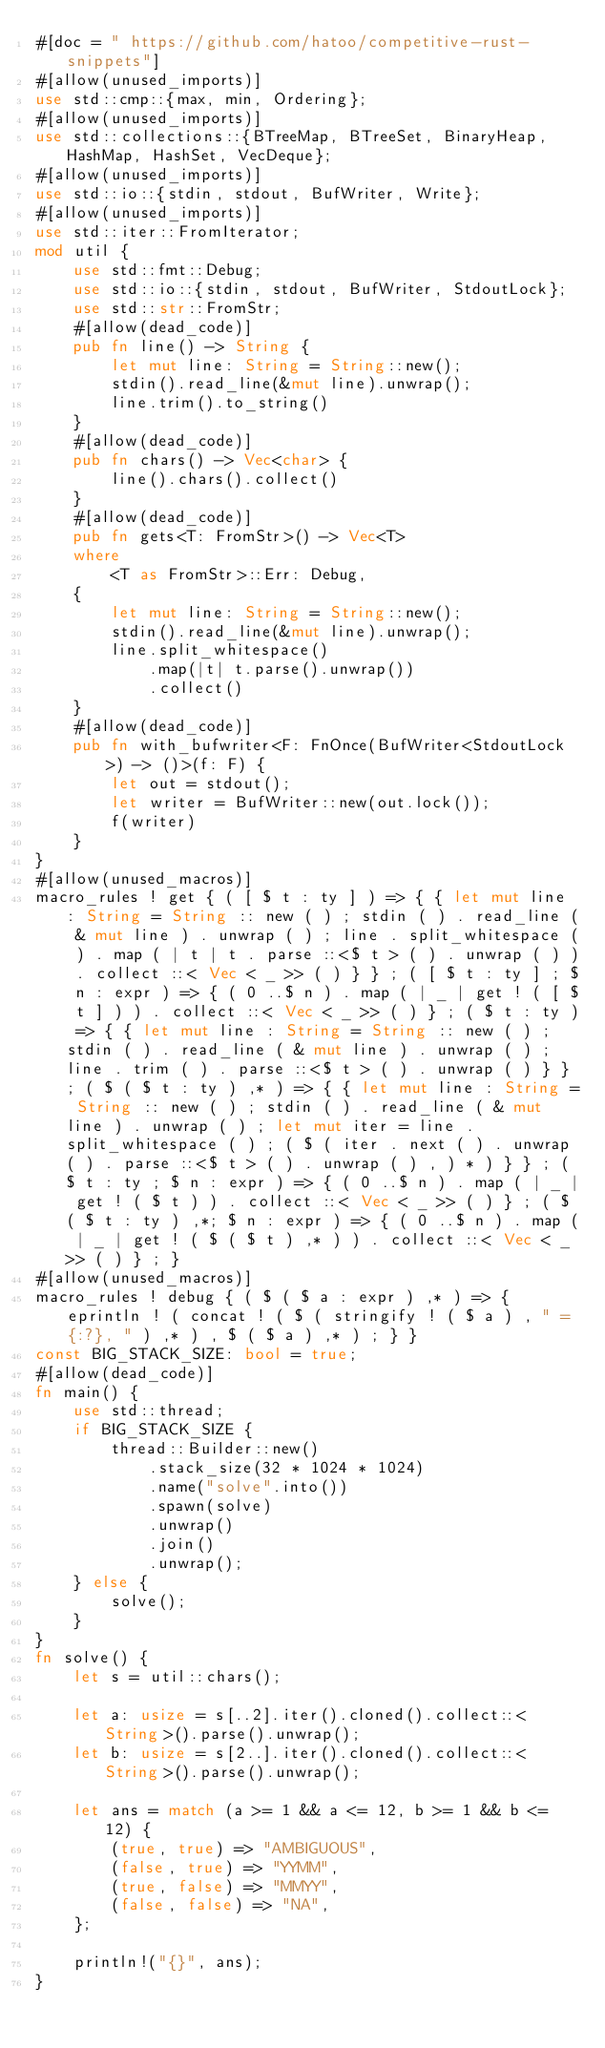Convert code to text. <code><loc_0><loc_0><loc_500><loc_500><_Rust_>#[doc = " https://github.com/hatoo/competitive-rust-snippets"]
#[allow(unused_imports)]
use std::cmp::{max, min, Ordering};
#[allow(unused_imports)]
use std::collections::{BTreeMap, BTreeSet, BinaryHeap, HashMap, HashSet, VecDeque};
#[allow(unused_imports)]
use std::io::{stdin, stdout, BufWriter, Write};
#[allow(unused_imports)]
use std::iter::FromIterator;
mod util {
    use std::fmt::Debug;
    use std::io::{stdin, stdout, BufWriter, StdoutLock};
    use std::str::FromStr;
    #[allow(dead_code)]
    pub fn line() -> String {
        let mut line: String = String::new();
        stdin().read_line(&mut line).unwrap();
        line.trim().to_string()
    }
    #[allow(dead_code)]
    pub fn chars() -> Vec<char> {
        line().chars().collect()
    }
    #[allow(dead_code)]
    pub fn gets<T: FromStr>() -> Vec<T>
    where
        <T as FromStr>::Err: Debug,
    {
        let mut line: String = String::new();
        stdin().read_line(&mut line).unwrap();
        line.split_whitespace()
            .map(|t| t.parse().unwrap())
            .collect()
    }
    #[allow(dead_code)]
    pub fn with_bufwriter<F: FnOnce(BufWriter<StdoutLock>) -> ()>(f: F) {
        let out = stdout();
        let writer = BufWriter::new(out.lock());
        f(writer)
    }
}
#[allow(unused_macros)]
macro_rules ! get { ( [ $ t : ty ] ) => { { let mut line : String = String :: new ( ) ; stdin ( ) . read_line ( & mut line ) . unwrap ( ) ; line . split_whitespace ( ) . map ( | t | t . parse ::<$ t > ( ) . unwrap ( ) ) . collect ::< Vec < _ >> ( ) } } ; ( [ $ t : ty ] ; $ n : expr ) => { ( 0 ..$ n ) . map ( | _ | get ! ( [ $ t ] ) ) . collect ::< Vec < _ >> ( ) } ; ( $ t : ty ) => { { let mut line : String = String :: new ( ) ; stdin ( ) . read_line ( & mut line ) . unwrap ( ) ; line . trim ( ) . parse ::<$ t > ( ) . unwrap ( ) } } ; ( $ ( $ t : ty ) ,* ) => { { let mut line : String = String :: new ( ) ; stdin ( ) . read_line ( & mut line ) . unwrap ( ) ; let mut iter = line . split_whitespace ( ) ; ( $ ( iter . next ( ) . unwrap ( ) . parse ::<$ t > ( ) . unwrap ( ) , ) * ) } } ; ( $ t : ty ; $ n : expr ) => { ( 0 ..$ n ) . map ( | _ | get ! ( $ t ) ) . collect ::< Vec < _ >> ( ) } ; ( $ ( $ t : ty ) ,*; $ n : expr ) => { ( 0 ..$ n ) . map ( | _ | get ! ( $ ( $ t ) ,* ) ) . collect ::< Vec < _ >> ( ) } ; }
#[allow(unused_macros)]
macro_rules ! debug { ( $ ( $ a : expr ) ,* ) => { eprintln ! ( concat ! ( $ ( stringify ! ( $ a ) , " = {:?}, " ) ,* ) , $ ( $ a ) ,* ) ; } }
const BIG_STACK_SIZE: bool = true;
#[allow(dead_code)]
fn main() {
    use std::thread;
    if BIG_STACK_SIZE {
        thread::Builder::new()
            .stack_size(32 * 1024 * 1024)
            .name("solve".into())
            .spawn(solve)
            .unwrap()
            .join()
            .unwrap();
    } else {
        solve();
    }
}
fn solve() {
    let s = util::chars();

    let a: usize = s[..2].iter().cloned().collect::<String>().parse().unwrap();
    let b: usize = s[2..].iter().cloned().collect::<String>().parse().unwrap();

    let ans = match (a >= 1 && a <= 12, b >= 1 && b <= 12) {
        (true, true) => "AMBIGUOUS",
        (false, true) => "YYMM",
        (true, false) => "MMYY",
        (false, false) => "NA",
    };

    println!("{}", ans);
}
</code> 